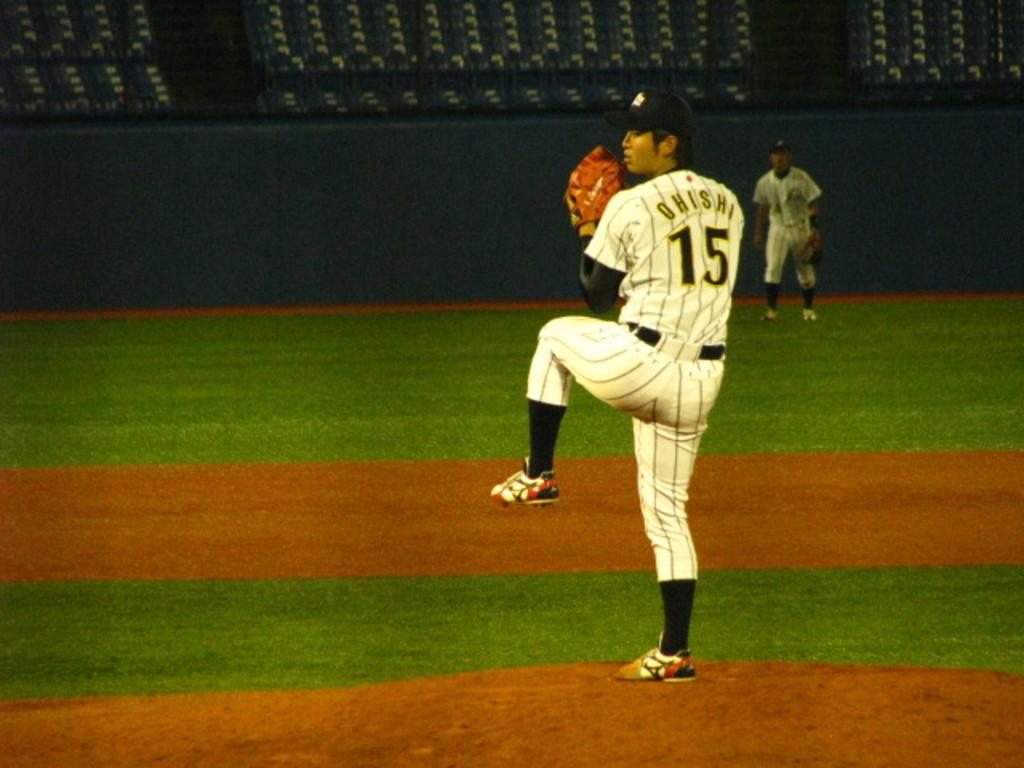What type of surface can be seen in the image? There is ground visible in the image. What structure is present in the image? There is a wall in the image. How many people are in the image? There are two people in the image. What color are the dresses worn by the two people? The two people are wearing white color dresses. What type of books can be seen on the edge of the wall in the image? There are no books present in the image, and the edge of the wall is not mentioned in the provided facts. 